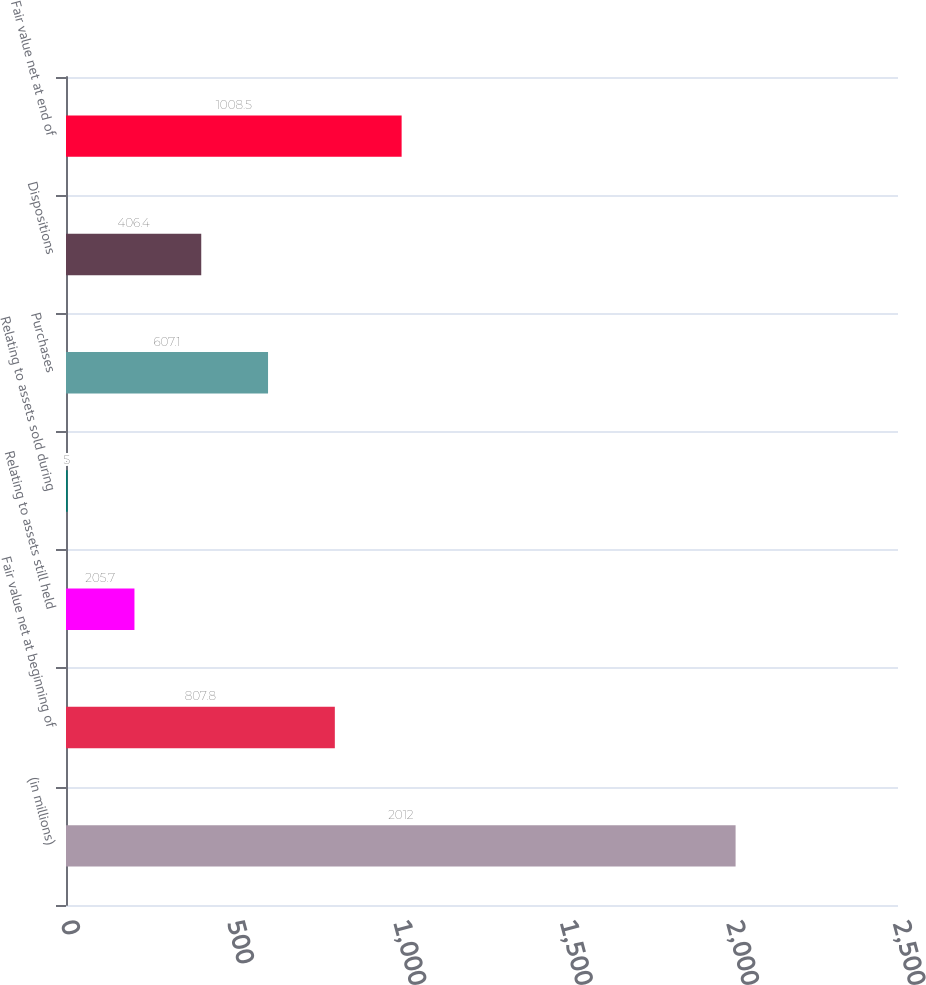Convert chart. <chart><loc_0><loc_0><loc_500><loc_500><bar_chart><fcel>(in millions)<fcel>Fair value net at beginning of<fcel>Relating to assets still held<fcel>Relating to assets sold during<fcel>Purchases<fcel>Dispositions<fcel>Fair value net at end of<nl><fcel>2012<fcel>807.8<fcel>205.7<fcel>5<fcel>607.1<fcel>406.4<fcel>1008.5<nl></chart> 